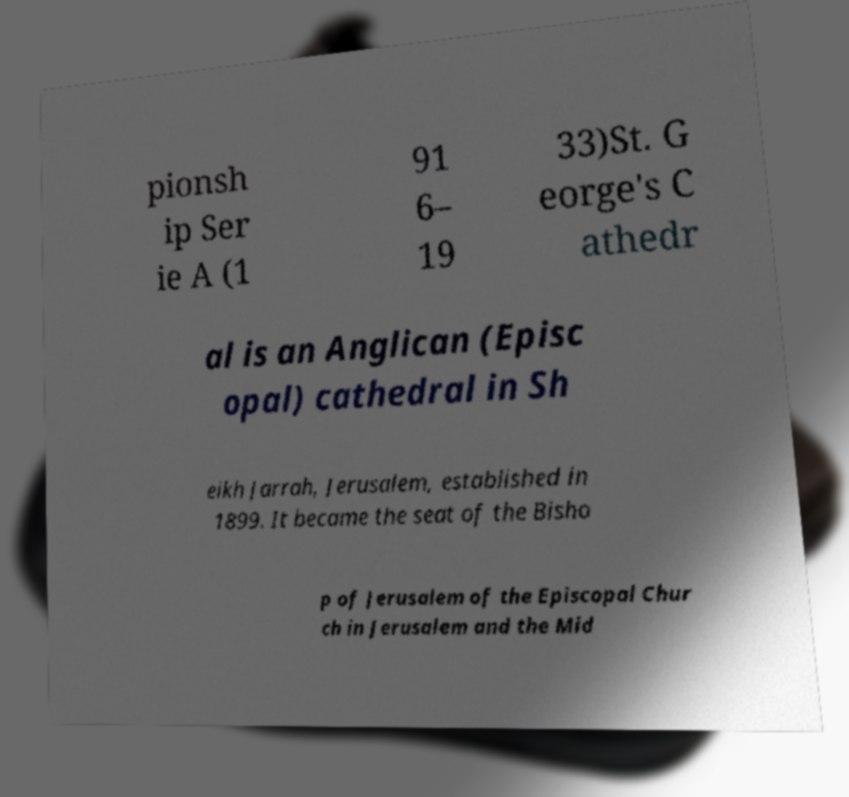Could you extract and type out the text from this image? pionsh ip Ser ie A (1 91 6– 19 33)St. G eorge's C athedr al is an Anglican (Episc opal) cathedral in Sh eikh Jarrah, Jerusalem, established in 1899. It became the seat of the Bisho p of Jerusalem of the Episcopal Chur ch in Jerusalem and the Mid 